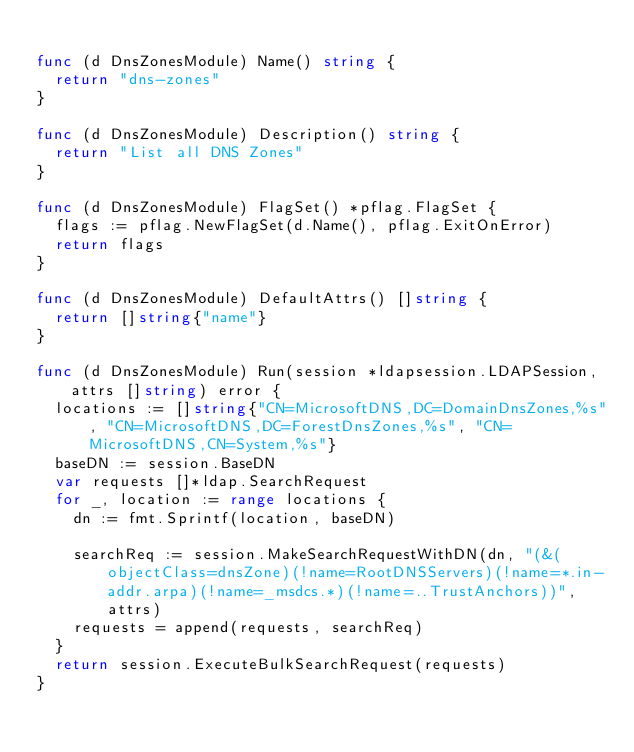Convert code to text. <code><loc_0><loc_0><loc_500><loc_500><_Go_>
func (d DnsZonesModule) Name() string {
	return "dns-zones"
}

func (d DnsZonesModule) Description() string {
	return "List all DNS Zones"
}

func (d DnsZonesModule) FlagSet() *pflag.FlagSet {
	flags := pflag.NewFlagSet(d.Name(), pflag.ExitOnError)
	return flags
}

func (d DnsZonesModule) DefaultAttrs() []string {
	return []string{"name"}
}

func (d DnsZonesModule) Run(session *ldapsession.LDAPSession, attrs []string) error {
	locations := []string{"CN=MicrosoftDNS,DC=DomainDnsZones,%s", "CN=MicrosoftDNS,DC=ForestDnsZones,%s", "CN=MicrosoftDNS,CN=System,%s"}
	baseDN := session.BaseDN
	var requests []*ldap.SearchRequest
	for _, location := range locations {
		dn := fmt.Sprintf(location, baseDN)

		searchReq := session.MakeSearchRequestWithDN(dn, "(&(objectClass=dnsZone)(!name=RootDNSServers)(!name=*.in-addr.arpa)(!name=_msdcs.*)(!name=..TrustAnchors))", attrs)
		requests = append(requests, searchReq)
	}
	return session.ExecuteBulkSearchRequest(requests)
}
</code> 